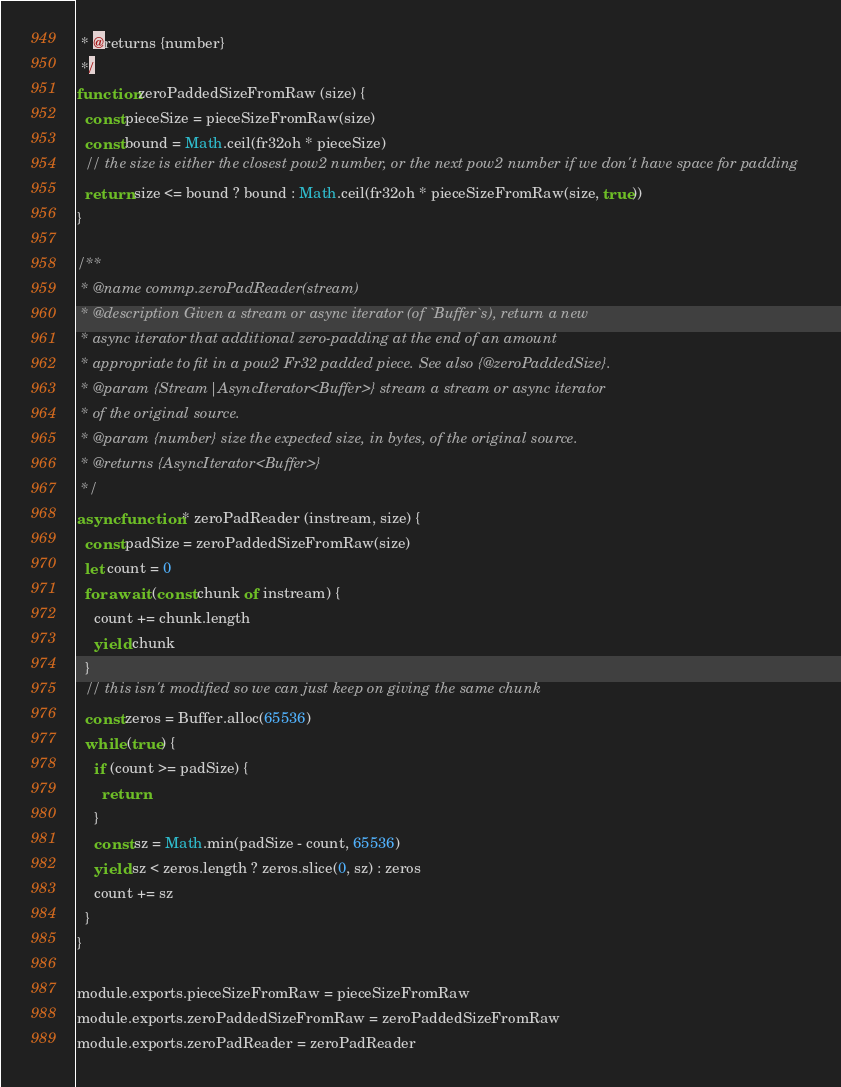Convert code to text. <code><loc_0><loc_0><loc_500><loc_500><_JavaScript_> * @returns {number}
 */
function zeroPaddedSizeFromRaw (size) {
  const pieceSize = pieceSizeFromRaw(size)
  const bound = Math.ceil(fr32oh * pieceSize)
  // the size is either the closest pow2 number, or the next pow2 number if we don't have space for padding
  return size <= bound ? bound : Math.ceil(fr32oh * pieceSizeFromRaw(size, true))
}

/**
 * @name commp.zeroPadReader(stream)
 * @description Given a stream or async iterator (of `Buffer`s), return a new
 * async iterator that additional zero-padding at the end of an amount
 * appropriate to fit in a pow2 Fr32 padded piece. See also {@zeroPaddedSize}.
 * @param {Stream|AsyncIterator<Buffer>} stream a stream or async iterator
 * of the original source.
 * @param {number} size the expected size, in bytes, of the original source.
 * @returns {AsyncIterator<Buffer>}
 */
async function * zeroPadReader (instream, size) {
  const padSize = zeroPaddedSizeFromRaw(size)
  let count = 0
  for await (const chunk of instream) {
    count += chunk.length
    yield chunk
  }
  // this isn't modified so we can just keep on giving the same chunk
  const zeros = Buffer.alloc(65536)
  while (true) {
    if (count >= padSize) {
      return
    }
    const sz = Math.min(padSize - count, 65536)
    yield sz < zeros.length ? zeros.slice(0, sz) : zeros
    count += sz
  }
}

module.exports.pieceSizeFromRaw = pieceSizeFromRaw
module.exports.zeroPaddedSizeFromRaw = zeroPaddedSizeFromRaw
module.exports.zeroPadReader = zeroPadReader
</code> 